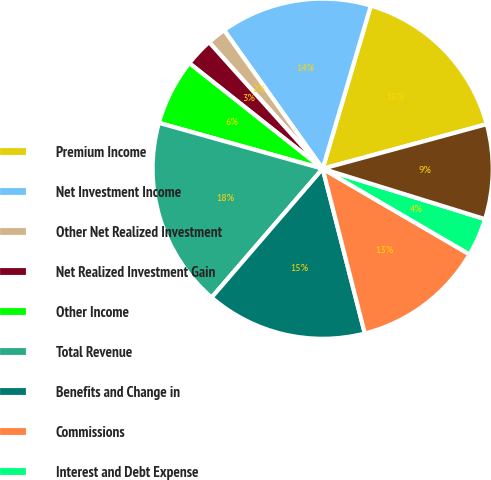Convert chart to OTSL. <chart><loc_0><loc_0><loc_500><loc_500><pie_chart><fcel>Premium Income<fcel>Net Investment Income<fcel>Other Net Realized Investment<fcel>Net Realized Investment Gain<fcel>Other Income<fcel>Total Revenue<fcel>Benefits and Change in<fcel>Commissions<fcel>Interest and Debt Expense<fcel>Deferral of Acquisition Costs<nl><fcel>16.21%<fcel>14.41%<fcel>1.8%<fcel>2.7%<fcel>6.31%<fcel>18.02%<fcel>15.31%<fcel>12.61%<fcel>3.61%<fcel>9.01%<nl></chart> 